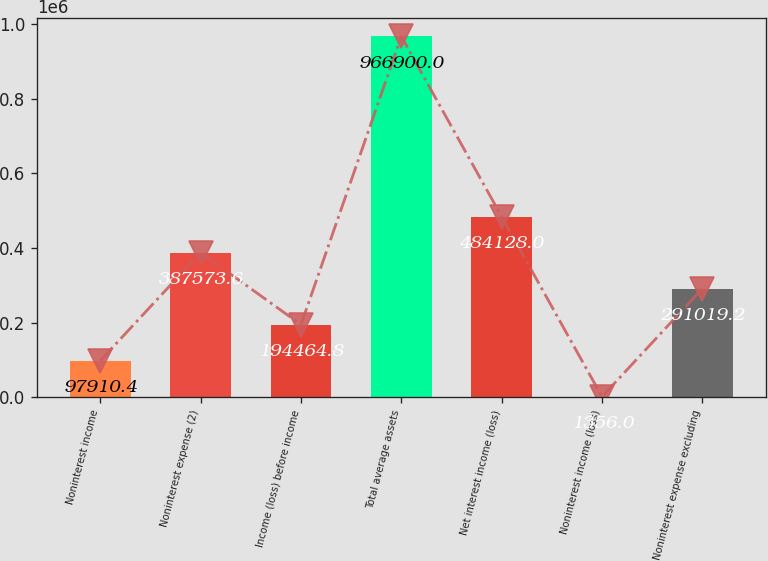Convert chart. <chart><loc_0><loc_0><loc_500><loc_500><bar_chart><fcel>Noninterest income<fcel>Noninterest expense (2)<fcel>Income (loss) before income<fcel>Total average assets<fcel>Net interest income (loss)<fcel>Noninterest income (loss)<fcel>Noninterest expense excluding<nl><fcel>97910.4<fcel>387574<fcel>194465<fcel>966900<fcel>484128<fcel>1356<fcel>291019<nl></chart> 